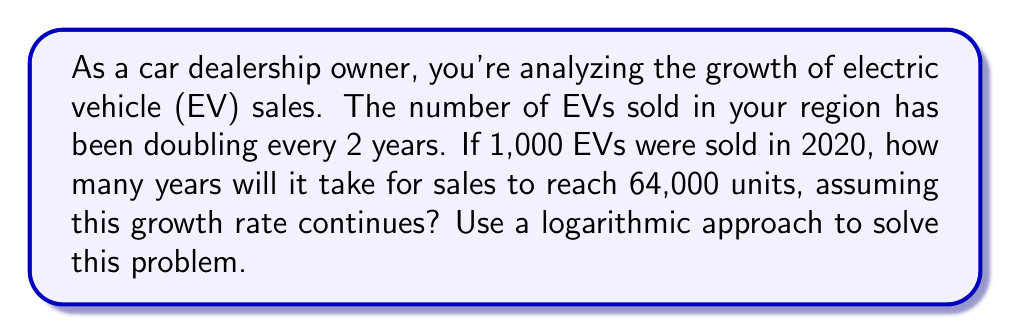Can you solve this math problem? Let's approach this step-by-step using logarithms:

1) First, let's define our variables:
   $y$ = number of years after 2020
   $N$ = number of EVs sold after $y$ years

2) We can express the growth as an exponential function:
   $N = 1000 \cdot 2^{\frac{y}{2}}$

3) We want to find $y$ when $N = 64,000$. Let's set up the equation:
   $64000 = 1000 \cdot 2^{\frac{y}{2}}$

4) Divide both sides by 1000:
   $64 = 2^{\frac{y}{2}}$

5) Now, let's apply logarithms (base 2) to both sides:
   $\log_2(64) = \log_2(2^{\frac{y}{2}})$

6) The right side simplifies due to the logarithm rule $\log_a(a^x) = x$:
   $\log_2(64) = \frac{y}{2}$

7) We know that $\log_2(64) = 6$ because $2^6 = 64$. So:
   $6 = \frac{y}{2}$

8) Solve for $y$:
   $y = 6 \cdot 2 = 12$

Therefore, it will take 12 years from 2020, which means EV sales will reach 64,000 units in 2032.
Answer: 12 years 